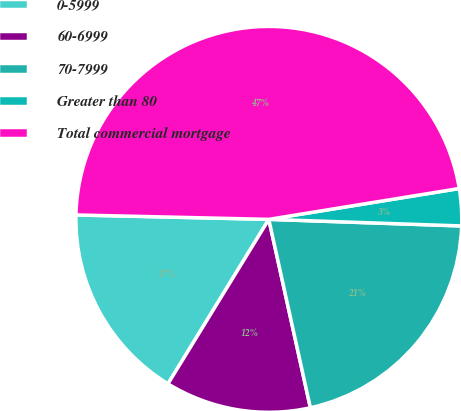Convert chart. <chart><loc_0><loc_0><loc_500><loc_500><pie_chart><fcel>0-5999<fcel>60-6999<fcel>70-7999<fcel>Greater than 80<fcel>Total commercial mortgage<nl><fcel>16.61%<fcel>12.21%<fcel>21.0%<fcel>3.1%<fcel>47.08%<nl></chart> 